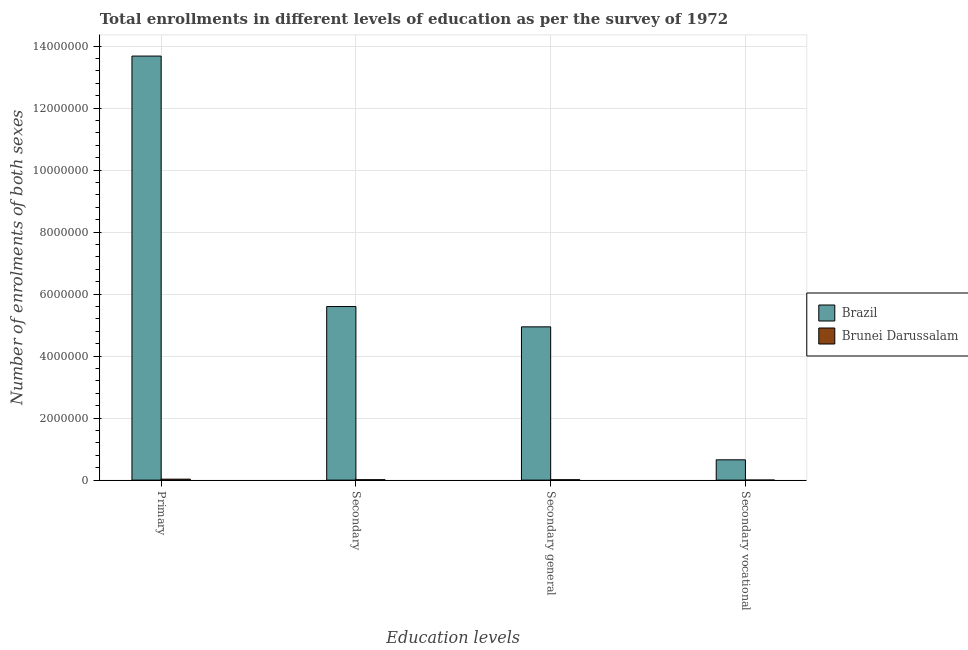How many different coloured bars are there?
Ensure brevity in your answer.  2. Are the number of bars per tick equal to the number of legend labels?
Offer a very short reply. Yes. What is the label of the 1st group of bars from the left?
Provide a succinct answer. Primary. What is the number of enrolments in secondary vocational education in Brazil?
Your response must be concise. 6.55e+05. Across all countries, what is the maximum number of enrolments in secondary education?
Make the answer very short. 5.60e+06. Across all countries, what is the minimum number of enrolments in primary education?
Your answer should be very brief. 3.07e+04. In which country was the number of enrolments in secondary general education minimum?
Provide a short and direct response. Brunei Darussalam. What is the total number of enrolments in secondary vocational education in the graph?
Ensure brevity in your answer.  6.56e+05. What is the difference between the number of enrolments in secondary vocational education in Brunei Darussalam and that in Brazil?
Your answer should be very brief. -6.55e+05. What is the difference between the number of enrolments in secondary vocational education in Brazil and the number of enrolments in secondary general education in Brunei Darussalam?
Ensure brevity in your answer.  6.43e+05. What is the average number of enrolments in primary education per country?
Keep it short and to the point. 6.85e+06. What is the difference between the number of enrolments in primary education and number of enrolments in secondary education in Brunei Darussalam?
Your answer should be very brief. 1.79e+04. In how many countries, is the number of enrolments in secondary education greater than 10400000 ?
Offer a terse response. 0. What is the ratio of the number of enrolments in secondary general education in Brazil to that in Brunei Darussalam?
Your response must be concise. 407.64. Is the number of enrolments in secondary general education in Brunei Darussalam less than that in Brazil?
Give a very brief answer. Yes. Is the difference between the number of enrolments in secondary vocational education in Brunei Darussalam and Brazil greater than the difference between the number of enrolments in secondary general education in Brunei Darussalam and Brazil?
Offer a terse response. Yes. What is the difference between the highest and the second highest number of enrolments in secondary general education?
Provide a short and direct response. 4.93e+06. What is the difference between the highest and the lowest number of enrolments in secondary vocational education?
Your response must be concise. 6.55e+05. Is the sum of the number of enrolments in primary education in Brunei Darussalam and Brazil greater than the maximum number of enrolments in secondary education across all countries?
Keep it short and to the point. Yes. What does the 2nd bar from the left in Primary represents?
Give a very brief answer. Brunei Darussalam. What does the 1st bar from the right in Secondary represents?
Your response must be concise. Brunei Darussalam. Is it the case that in every country, the sum of the number of enrolments in primary education and number of enrolments in secondary education is greater than the number of enrolments in secondary general education?
Keep it short and to the point. Yes. Are all the bars in the graph horizontal?
Make the answer very short. No. How many countries are there in the graph?
Give a very brief answer. 2. Are the values on the major ticks of Y-axis written in scientific E-notation?
Your answer should be very brief. No. Does the graph contain any zero values?
Keep it short and to the point. No. Does the graph contain grids?
Offer a very short reply. Yes. Where does the legend appear in the graph?
Offer a terse response. Center right. What is the title of the graph?
Make the answer very short. Total enrollments in different levels of education as per the survey of 1972. Does "Namibia" appear as one of the legend labels in the graph?
Make the answer very short. No. What is the label or title of the X-axis?
Provide a succinct answer. Education levels. What is the label or title of the Y-axis?
Make the answer very short. Number of enrolments of both sexes. What is the Number of enrolments of both sexes in Brazil in Primary?
Ensure brevity in your answer.  1.37e+07. What is the Number of enrolments of both sexes in Brunei Darussalam in Primary?
Offer a terse response. 3.07e+04. What is the Number of enrolments of both sexes in Brazil in Secondary?
Offer a terse response. 5.60e+06. What is the Number of enrolments of both sexes in Brunei Darussalam in Secondary?
Your response must be concise. 1.28e+04. What is the Number of enrolments of both sexes in Brazil in Secondary general?
Provide a short and direct response. 4.94e+06. What is the Number of enrolments of both sexes of Brunei Darussalam in Secondary general?
Ensure brevity in your answer.  1.21e+04. What is the Number of enrolments of both sexes of Brazil in Secondary vocational?
Make the answer very short. 6.55e+05. What is the Number of enrolments of both sexes in Brunei Darussalam in Secondary vocational?
Make the answer very short. 638. Across all Education levels, what is the maximum Number of enrolments of both sexes of Brazil?
Make the answer very short. 1.37e+07. Across all Education levels, what is the maximum Number of enrolments of both sexes of Brunei Darussalam?
Ensure brevity in your answer.  3.07e+04. Across all Education levels, what is the minimum Number of enrolments of both sexes of Brazil?
Keep it short and to the point. 6.55e+05. Across all Education levels, what is the minimum Number of enrolments of both sexes in Brunei Darussalam?
Offer a terse response. 638. What is the total Number of enrolments of both sexes in Brazil in the graph?
Make the answer very short. 2.49e+07. What is the total Number of enrolments of both sexes of Brunei Darussalam in the graph?
Make the answer very short. 5.62e+04. What is the difference between the Number of enrolments of both sexes of Brazil in Primary and that in Secondary?
Make the answer very short. 8.08e+06. What is the difference between the Number of enrolments of both sexes in Brunei Darussalam in Primary and that in Secondary?
Your answer should be compact. 1.79e+04. What is the difference between the Number of enrolments of both sexes in Brazil in Primary and that in Secondary general?
Give a very brief answer. 8.73e+06. What is the difference between the Number of enrolments of both sexes in Brunei Darussalam in Primary and that in Secondary general?
Your answer should be compact. 1.85e+04. What is the difference between the Number of enrolments of both sexes of Brazil in Primary and that in Secondary vocational?
Provide a succinct answer. 1.30e+07. What is the difference between the Number of enrolments of both sexes of Brunei Darussalam in Primary and that in Secondary vocational?
Keep it short and to the point. 3.00e+04. What is the difference between the Number of enrolments of both sexes of Brazil in Secondary and that in Secondary general?
Ensure brevity in your answer.  6.55e+05. What is the difference between the Number of enrolments of both sexes in Brunei Darussalam in Secondary and that in Secondary general?
Ensure brevity in your answer.  638. What is the difference between the Number of enrolments of both sexes in Brazil in Secondary and that in Secondary vocational?
Provide a short and direct response. 4.94e+06. What is the difference between the Number of enrolments of both sexes in Brunei Darussalam in Secondary and that in Secondary vocational?
Provide a succinct answer. 1.21e+04. What is the difference between the Number of enrolments of both sexes of Brazil in Secondary general and that in Secondary vocational?
Offer a very short reply. 4.29e+06. What is the difference between the Number of enrolments of both sexes in Brunei Darussalam in Secondary general and that in Secondary vocational?
Provide a succinct answer. 1.15e+04. What is the difference between the Number of enrolments of both sexes in Brazil in Primary and the Number of enrolments of both sexes in Brunei Darussalam in Secondary?
Offer a terse response. 1.37e+07. What is the difference between the Number of enrolments of both sexes of Brazil in Primary and the Number of enrolments of both sexes of Brunei Darussalam in Secondary general?
Your response must be concise. 1.37e+07. What is the difference between the Number of enrolments of both sexes in Brazil in Primary and the Number of enrolments of both sexes in Brunei Darussalam in Secondary vocational?
Your answer should be compact. 1.37e+07. What is the difference between the Number of enrolments of both sexes in Brazil in Secondary and the Number of enrolments of both sexes in Brunei Darussalam in Secondary general?
Offer a terse response. 5.59e+06. What is the difference between the Number of enrolments of both sexes in Brazil in Secondary and the Number of enrolments of both sexes in Brunei Darussalam in Secondary vocational?
Offer a very short reply. 5.60e+06. What is the difference between the Number of enrolments of both sexes in Brazil in Secondary general and the Number of enrolments of both sexes in Brunei Darussalam in Secondary vocational?
Offer a very short reply. 4.94e+06. What is the average Number of enrolments of both sexes of Brazil per Education levels?
Give a very brief answer. 6.22e+06. What is the average Number of enrolments of both sexes of Brunei Darussalam per Education levels?
Provide a short and direct response. 1.40e+04. What is the difference between the Number of enrolments of both sexes in Brazil and Number of enrolments of both sexes in Brunei Darussalam in Primary?
Provide a short and direct response. 1.36e+07. What is the difference between the Number of enrolments of both sexes in Brazil and Number of enrolments of both sexes in Brunei Darussalam in Secondary?
Offer a terse response. 5.59e+06. What is the difference between the Number of enrolments of both sexes in Brazil and Number of enrolments of both sexes in Brunei Darussalam in Secondary general?
Provide a short and direct response. 4.93e+06. What is the difference between the Number of enrolments of both sexes in Brazil and Number of enrolments of both sexes in Brunei Darussalam in Secondary vocational?
Make the answer very short. 6.55e+05. What is the ratio of the Number of enrolments of both sexes in Brazil in Primary to that in Secondary?
Offer a terse response. 2.44. What is the ratio of the Number of enrolments of both sexes of Brunei Darussalam in Primary to that in Secondary?
Your answer should be very brief. 2.4. What is the ratio of the Number of enrolments of both sexes in Brazil in Primary to that in Secondary general?
Ensure brevity in your answer.  2.77. What is the ratio of the Number of enrolments of both sexes in Brunei Darussalam in Primary to that in Secondary general?
Offer a terse response. 2.53. What is the ratio of the Number of enrolments of both sexes of Brazil in Primary to that in Secondary vocational?
Your answer should be compact. 20.87. What is the ratio of the Number of enrolments of both sexes of Brunei Darussalam in Primary to that in Secondary vocational?
Offer a terse response. 48.04. What is the ratio of the Number of enrolments of both sexes in Brazil in Secondary to that in Secondary general?
Provide a short and direct response. 1.13. What is the ratio of the Number of enrolments of both sexes of Brunei Darussalam in Secondary to that in Secondary general?
Make the answer very short. 1.05. What is the ratio of the Number of enrolments of both sexes in Brazil in Secondary to that in Secondary vocational?
Give a very brief answer. 8.55. What is the ratio of the Number of enrolments of both sexes of Brunei Darussalam in Secondary to that in Secondary vocational?
Ensure brevity in your answer.  20.01. What is the ratio of the Number of enrolments of both sexes in Brazil in Secondary general to that in Secondary vocational?
Ensure brevity in your answer.  7.55. What is the ratio of the Number of enrolments of both sexes in Brunei Darussalam in Secondary general to that in Secondary vocational?
Give a very brief answer. 19.01. What is the difference between the highest and the second highest Number of enrolments of both sexes of Brazil?
Make the answer very short. 8.08e+06. What is the difference between the highest and the second highest Number of enrolments of both sexes in Brunei Darussalam?
Give a very brief answer. 1.79e+04. What is the difference between the highest and the lowest Number of enrolments of both sexes of Brazil?
Offer a very short reply. 1.30e+07. What is the difference between the highest and the lowest Number of enrolments of both sexes in Brunei Darussalam?
Make the answer very short. 3.00e+04. 